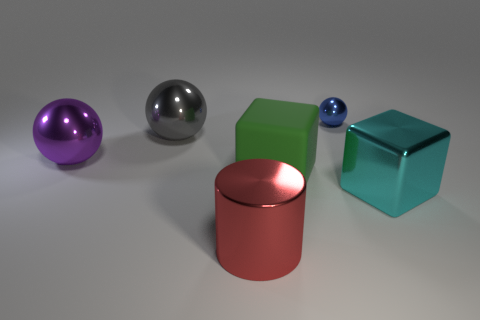What is the color of the shiny cylinder that is the same size as the gray metallic ball?
Offer a terse response. Red. Is there anything else that is the same shape as the large red thing?
Provide a succinct answer. No. What is the color of the other large thing that is the same shape as the rubber thing?
Your answer should be very brief. Cyan. What number of objects are tiny purple metallic cubes or big metal things that are on the left side of the big red metallic cylinder?
Your response must be concise. 2. Are there fewer blue things that are in front of the purple metal ball than big gray shiny objects?
Offer a terse response. Yes. What size is the object behind the gray ball behind the big cube that is on the left side of the cyan thing?
Ensure brevity in your answer.  Small. What color is the metallic object that is in front of the purple thing and on the right side of the big rubber object?
Your response must be concise. Cyan. What number of red cylinders are there?
Offer a terse response. 1. Is there anything else that has the same size as the blue ball?
Provide a succinct answer. No. Are the purple sphere and the big cyan thing made of the same material?
Give a very brief answer. Yes. 